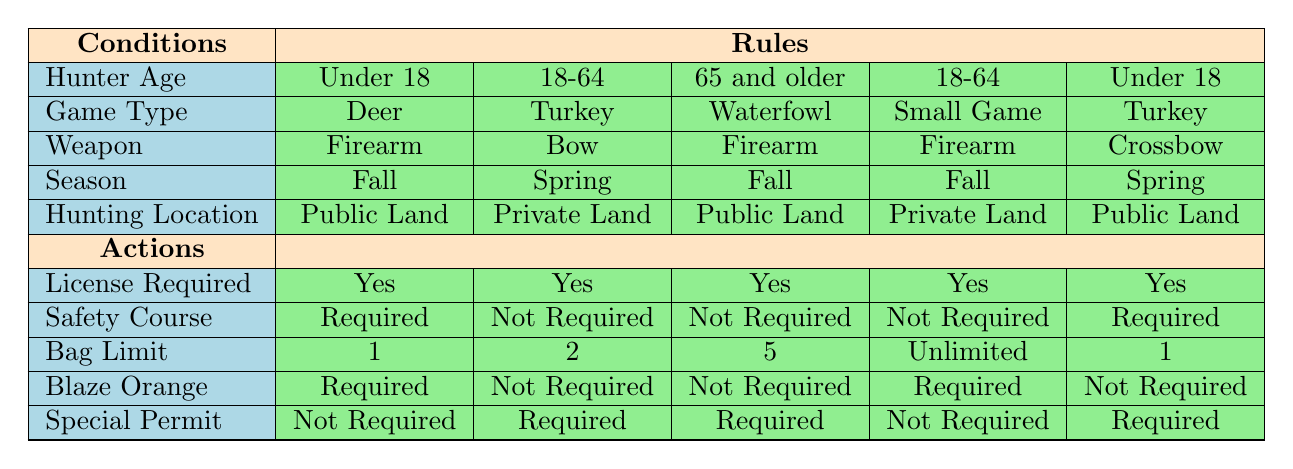What license is required for an 18-64 year old hunting deer with a firearm in the fall on private land? The table specifies that for an 18-64 year old hunting deer with a firearm in the fall on private land, a license is required. This rule can be found in the actions associated with the conditions that match this scenario.
Answer: Yes Is a safety course required for someone over 65 hunting waterfowl with a firearm on public land in the fall? According to the table, for individuals aged 65 and older hunting waterfowl with a firearm on public land during the fall, a safety course is not required. This is indicated in the actions related to these specific conditions.
Answer: No What is the bag limit for an individual under 18 hunting turkey with a crossbow in spring on public land? The table shows that the bag limit for someone under 18 hunting turkey with a crossbow in spring on public land is 1. This can be found in the actions that correlate with these conditions.
Answer: 1 How many hunting season requirements list "not required" for blaze orange when hunting small game with a firearm on private land in fall for ages 18-64? In this scenario, the table shows that blaze orange is required. Since it is not "not required," the answer reflects that there are no listings of "not required." Thus, the requirements do not fit this condition.
Answer: 0 Do hunters aged 65 and older require a special permit for hunting waterfowl with a firearm on public land in the fall? The table states that for hunters 65 and older hunting waterfowl with a firearm on public land in the fall, a special permit is required. This information is easily pulled from the actions outlined for these conditions.
Answer: Yes What percentage of conditions for an 18-64 year old hunting turkey with a bow in spring on private land require a safety course? There is only one listing that matches this specific combination, and it shows that a safety course is not required. Since there is only one data point, the percentage of requirements that state "not required" is 100% for this case.
Answer: 100% How many total actions are required for an under 18 year old hunting deer with a firearm in fall on public land? For an under 18 year old hunting deer with a firearm in fall on public land, the actions are: License Required (Yes), Safety Course (Required), Bag Limit (1), Blaze Orange (Required), and Special Permit (Not Required). Counting these gives a total of 4 actions.
Answer: 4 